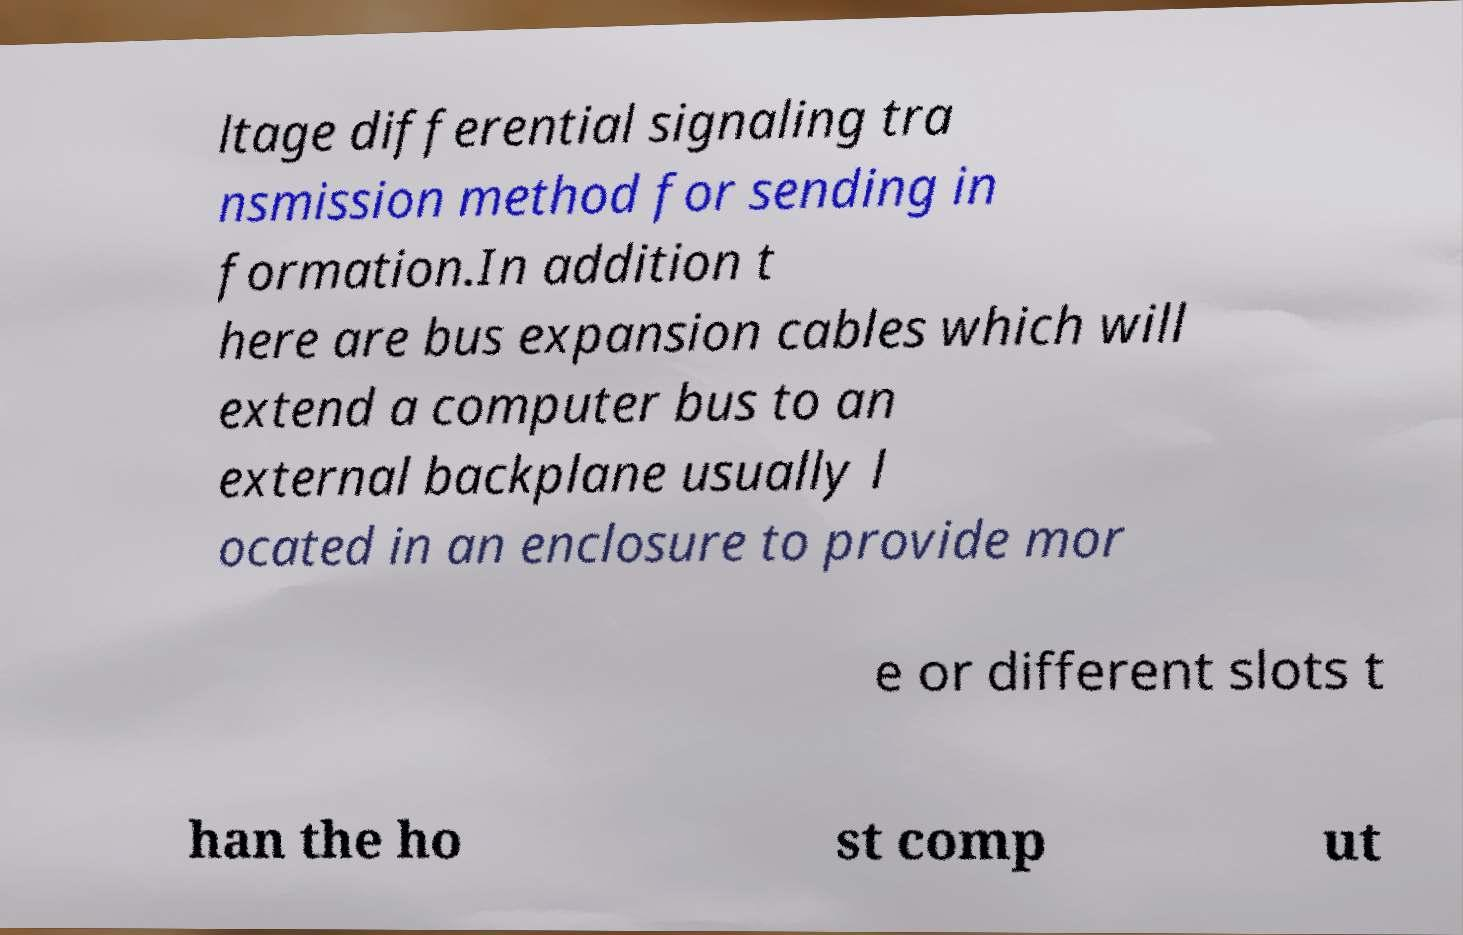Could you extract and type out the text from this image? ltage differential signaling tra nsmission method for sending in formation.In addition t here are bus expansion cables which will extend a computer bus to an external backplane usually l ocated in an enclosure to provide mor e or different slots t han the ho st comp ut 